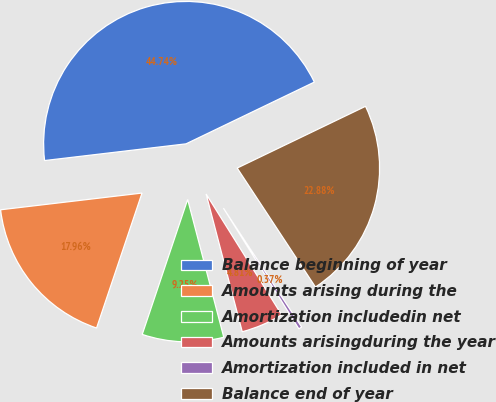Convert chart to OTSL. <chart><loc_0><loc_0><loc_500><loc_500><pie_chart><fcel>Balance beginning of year<fcel>Amounts arising during the<fcel>Amortization includedin net<fcel>Amounts arisingduring the year<fcel>Amortization included in net<fcel>Balance end of year<nl><fcel>44.74%<fcel>17.96%<fcel>9.25%<fcel>4.81%<fcel>0.37%<fcel>22.88%<nl></chart> 